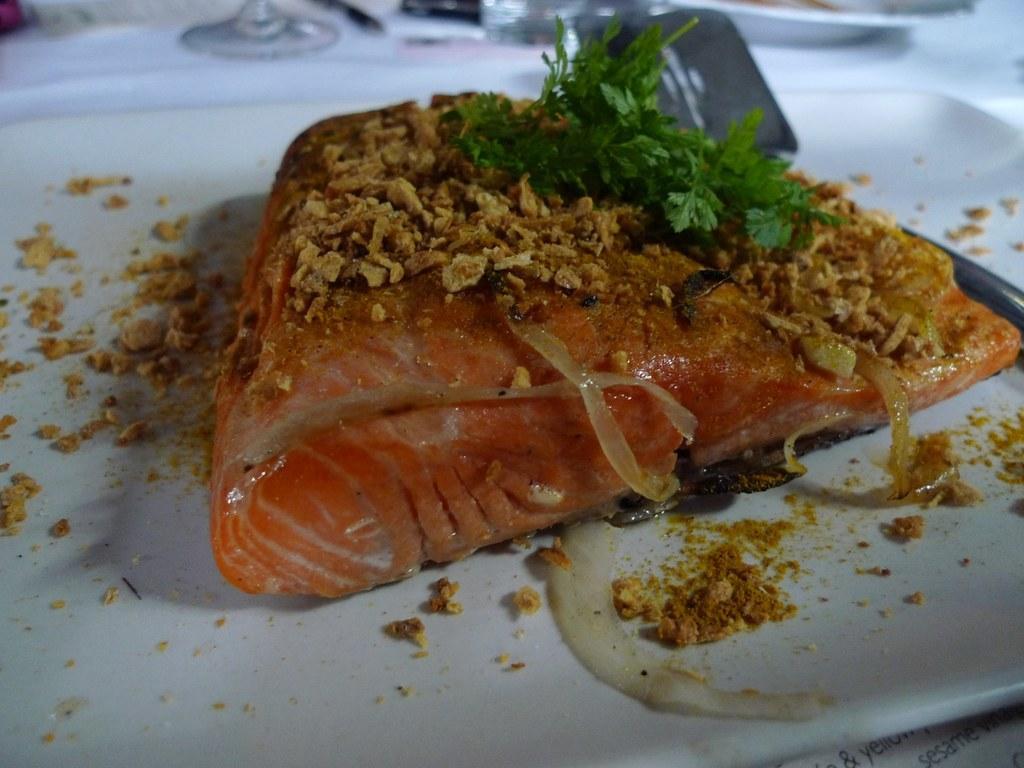In one or two sentences, can you explain what this image depicts? In this image we can see a food item on a plate. At the top of the image, we can see glasses and a plate. 